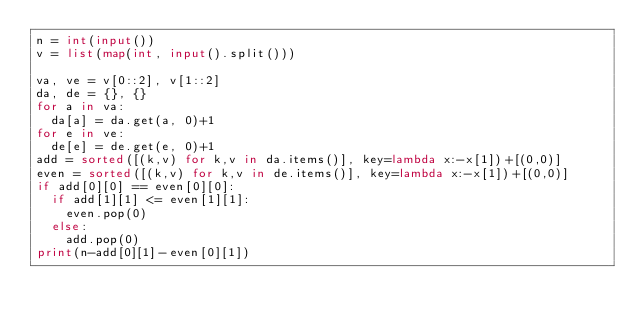Convert code to text. <code><loc_0><loc_0><loc_500><loc_500><_Python_>n = int(input())
v = list(map(int, input().split()))

va, ve = v[0::2], v[1::2]
da, de = {}, {}
for a in va:
  da[a] = da.get(a, 0)+1
for e in ve:
  de[e] = de.get(e, 0)+1
add = sorted([(k,v) for k,v in da.items()], key=lambda x:-x[1])+[(0,0)]
even = sorted([(k,v) for k,v in de.items()], key=lambda x:-x[1])+[(0,0)]
if add[0][0] == even[0][0]:
  if add[1][1] <= even[1][1]:
    even.pop(0)
  else:
    add.pop(0)
print(n-add[0][1]-even[0][1])</code> 